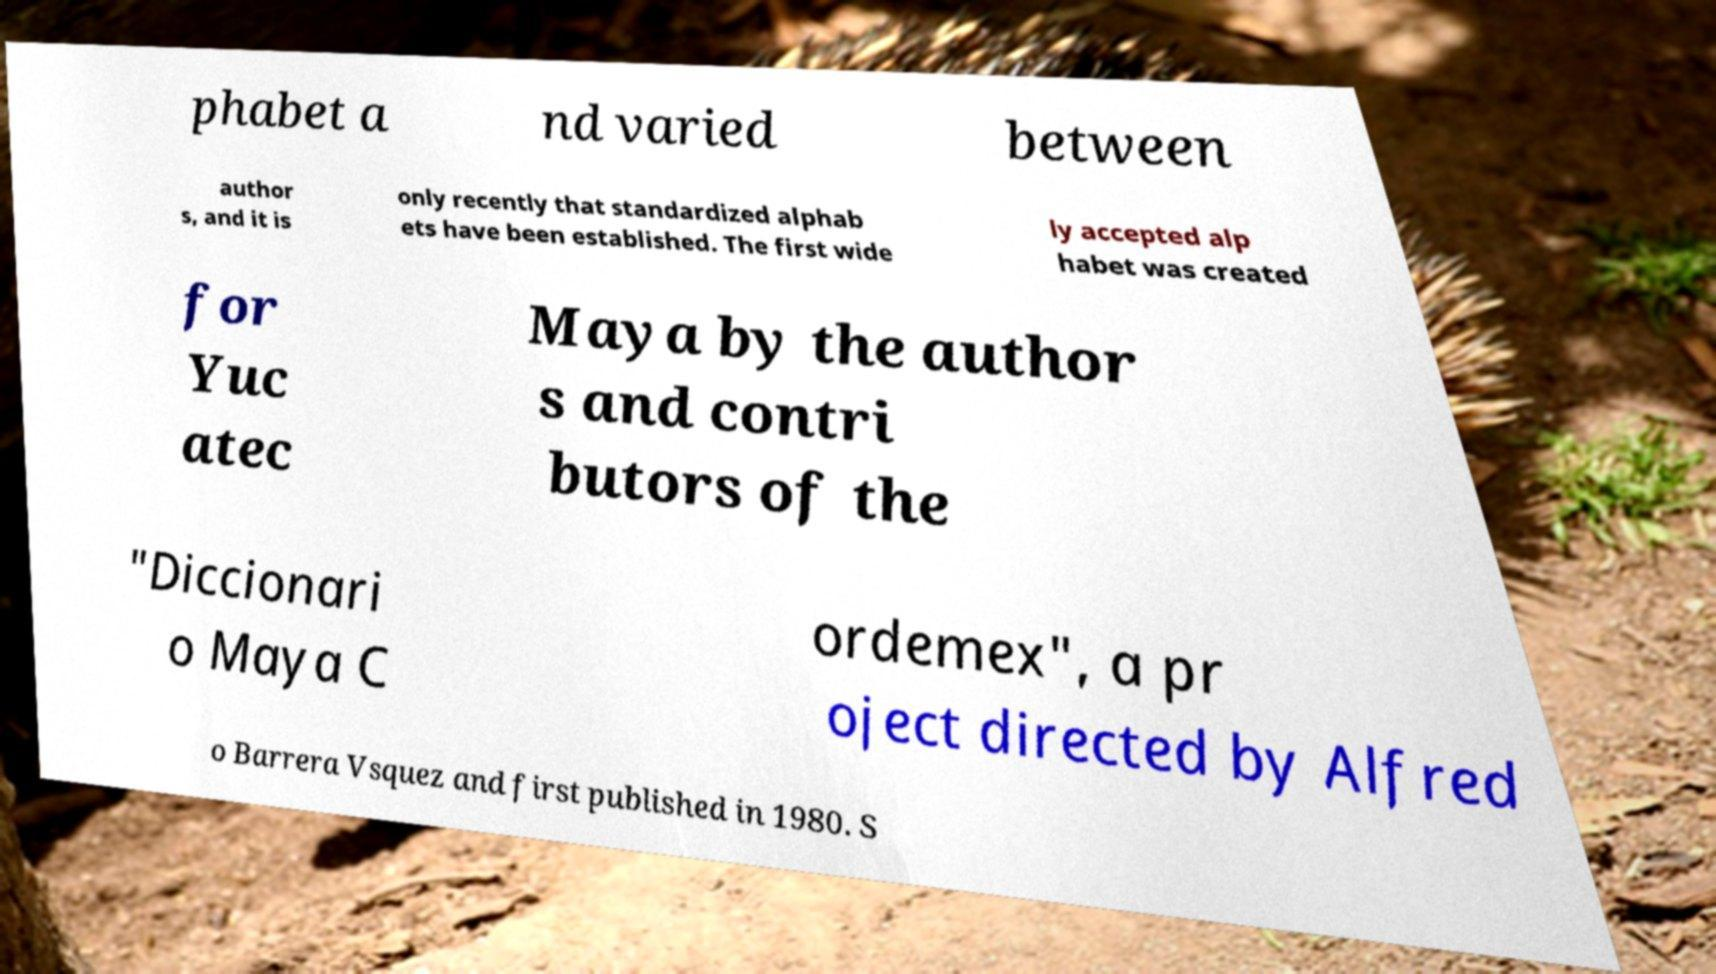Please read and relay the text visible in this image. What does it say? phabet a nd varied between author s, and it is only recently that standardized alphab ets have been established. The first wide ly accepted alp habet was created for Yuc atec Maya by the author s and contri butors of the "Diccionari o Maya C ordemex", a pr oject directed by Alfred o Barrera Vsquez and first published in 1980. S 